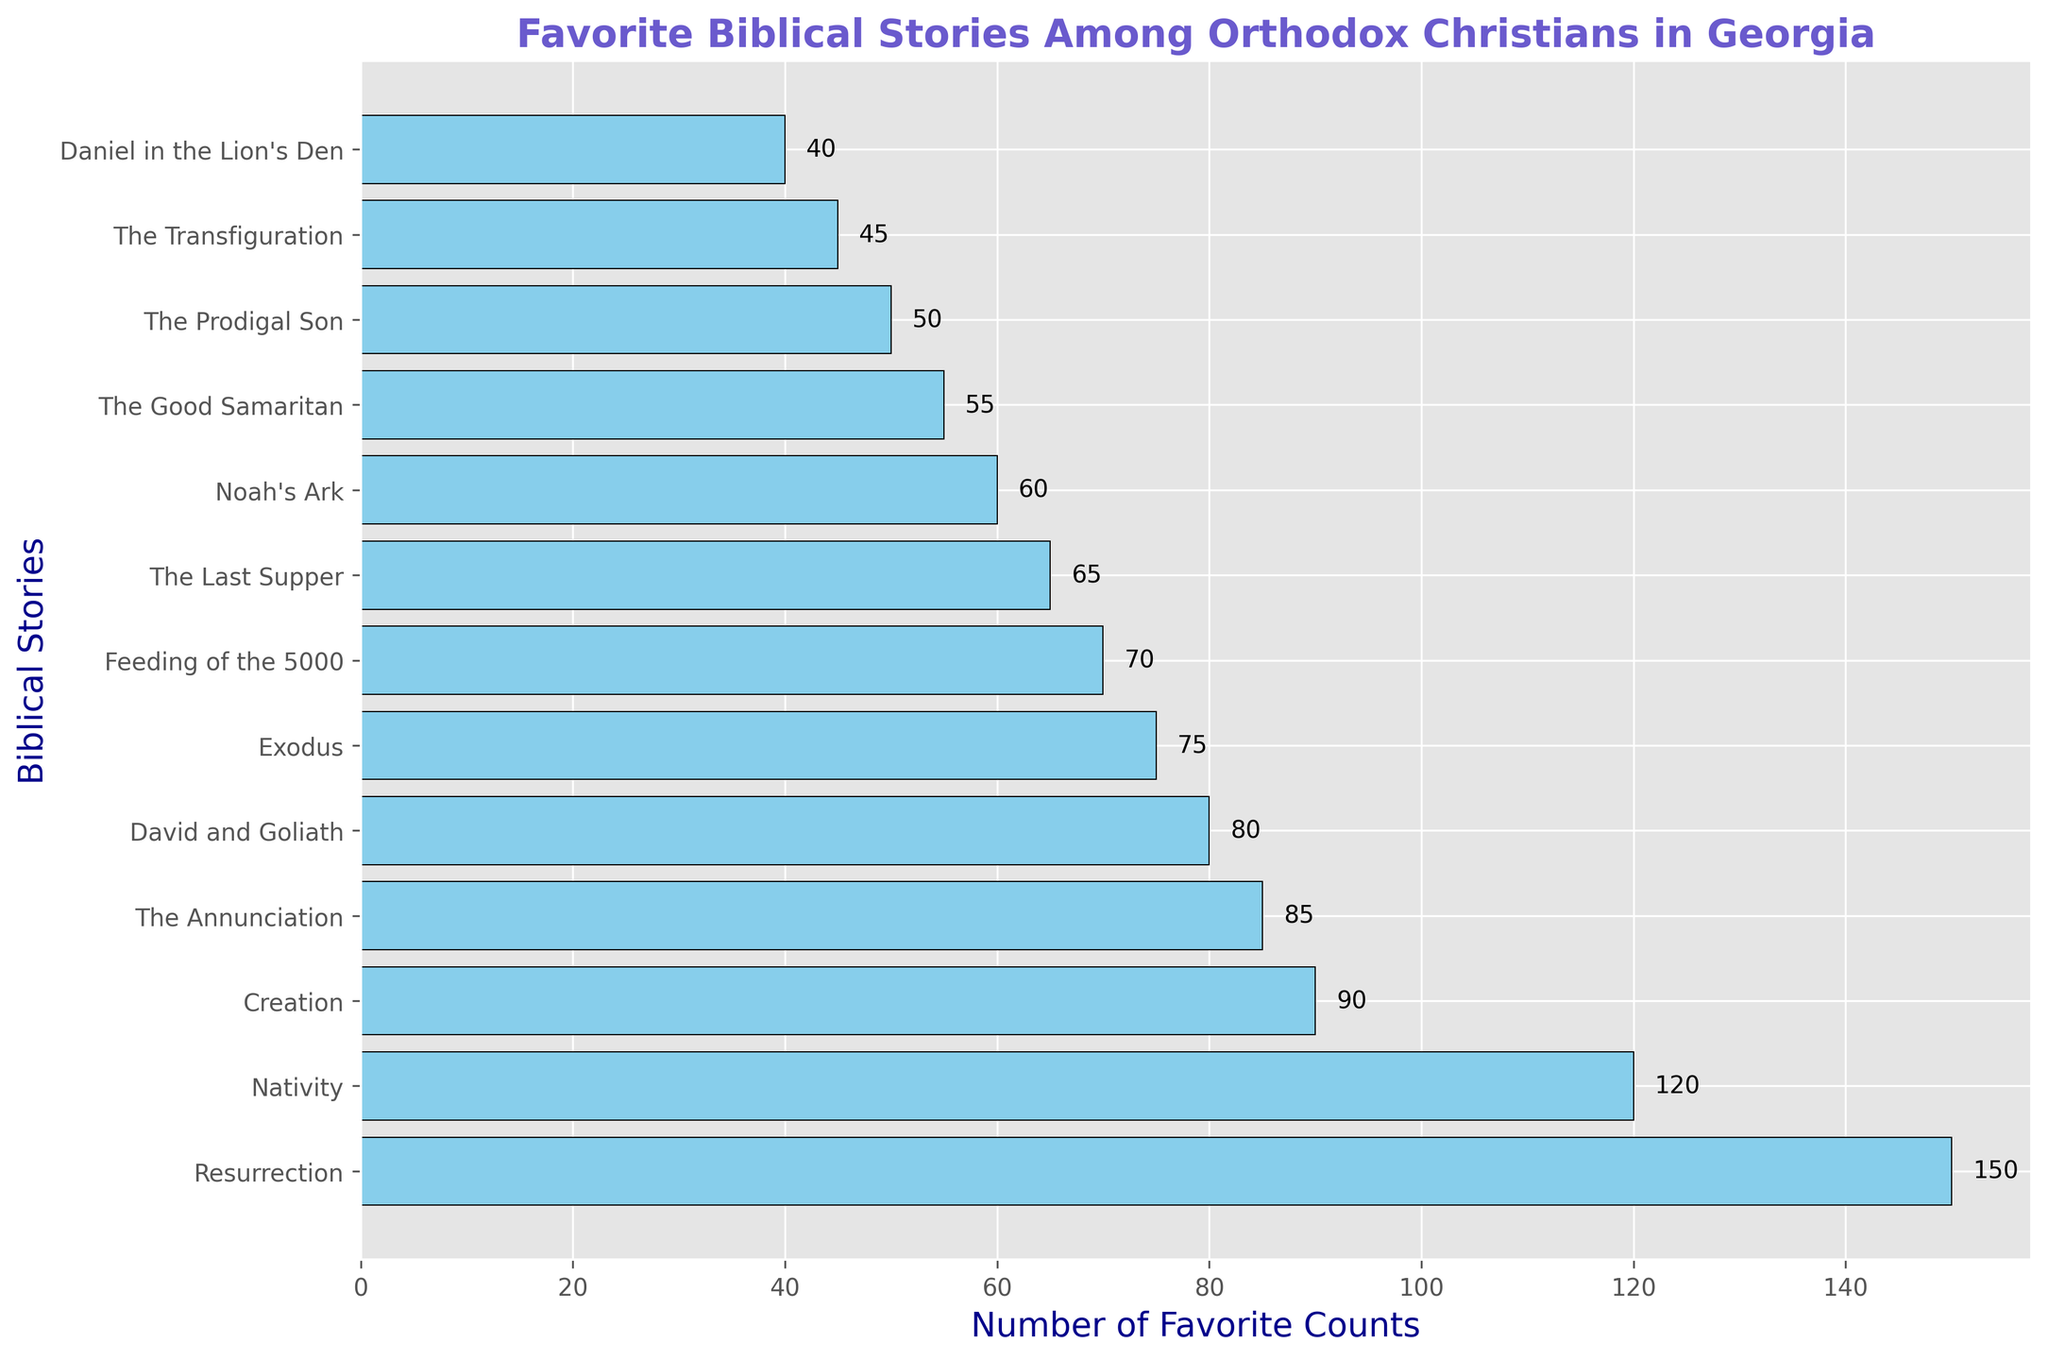What's the most favorite Biblical story among Orthodox Christians in Georgia? The most favorite story will have the highest bar indicating the highest count. From the figure, the "Resurrection" has the highest bar.
Answer: The Resurrection Which story has the fewest favorite counts? The least favorite story will have the shortest bar indicating the lowest count. From the figure, "Daniel in the Lion's Den" has the shortest bar.
Answer: Daniel in the Lion's Den What's the total count of favorite stories for "Nativity" and "Creation"? To find the total, add the favorite counts of these two stories: "Nativity" (120) + "Creation" (90). Total = 120 + 90 = 210.
Answer: 210 How many stories have a favorite count above 100? Check the count for each story and see how many have a bar length exceeding 100. From the figure, there are two: "Nativity" (120) and "Resurrection" (150).
Answer: 2 Which is more favored: "The Good Samaritan" or "Feeding of the 5000"? Compare the heights of the bars for these two stories. "The Good Samaritan" (55) has a shorter bar than "Feeding of the 5000" (70).
Answer: Feeding of the 5000 What is the difference in favorite counts between "David and Goliath" and "Noah's Ark"? Subtract the count of "Noah's Ark" (60) from "David and Goliath" (80). Difference = 80 - 60 = 20.
Answer: 20 What's the average favorite count of stories with counts more than 50 but less than 100? Calculate the average of stories with counts: "Nativity" (120 excluded), "Creation" (90), "Exodus" (75), "David and Goliath" (80), "Noah's Ark" (60), "The Good Samaritan" (55). (90 + 75 + 80 + 60 + 55) / 5 = 72.
Answer: 72 What percentage of the total favorite counts does the "Resurrection" represent? First, calculate the total counts of all stories. Then, find the percentage for "Resurrection" (150). Total sum = 120 + 150 + 90 + 75 + 80 + 60 + 55 + 50 + 40 + 65 + 70 + 45 + 85 = 985.
Percentage = (150 / 985) * 100 ≈ 15.23%.
Answer: 15.23% How many stories have a favorite count of exactly 85? Look for the story with a count of 85. From the figure, "The Annunciation" has a count of 85. There's only one.
Answer: 1 Which three stories have the highest favorite counts? The top three stories with the highest bars are: "Resurrection" (150), "Nativity" (120), and "Creation" (90).
Answer: Resurrection, Nativity, Creation 